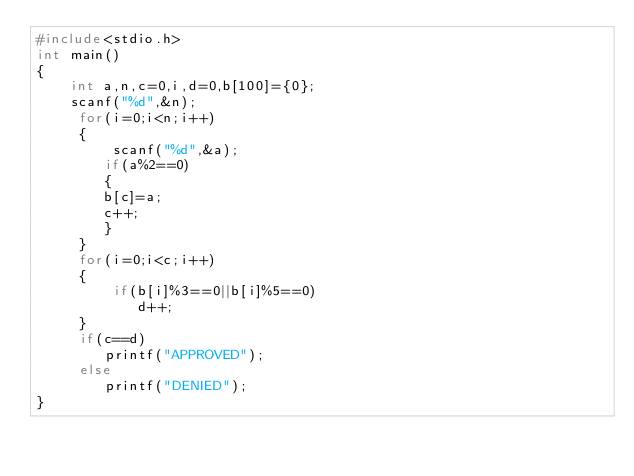Convert code to text. <code><loc_0><loc_0><loc_500><loc_500><_C_>#include<stdio.h>
int main()
{
    int a,n,c=0,i,d=0,b[100]={0};
    scanf("%d",&n);
     for(i=0;i<n;i++)
     {
         scanf("%d",&a);
        if(a%2==0)
        {
        b[c]=a;
        c++;
        }
     }
     for(i=0;i<c;i++)
     {
         if(b[i]%3==0||b[i]%5==0)
            d++;
     }
     if(c==d)
        printf("APPROVED");
     else
        printf("DENIED");
}
</code> 